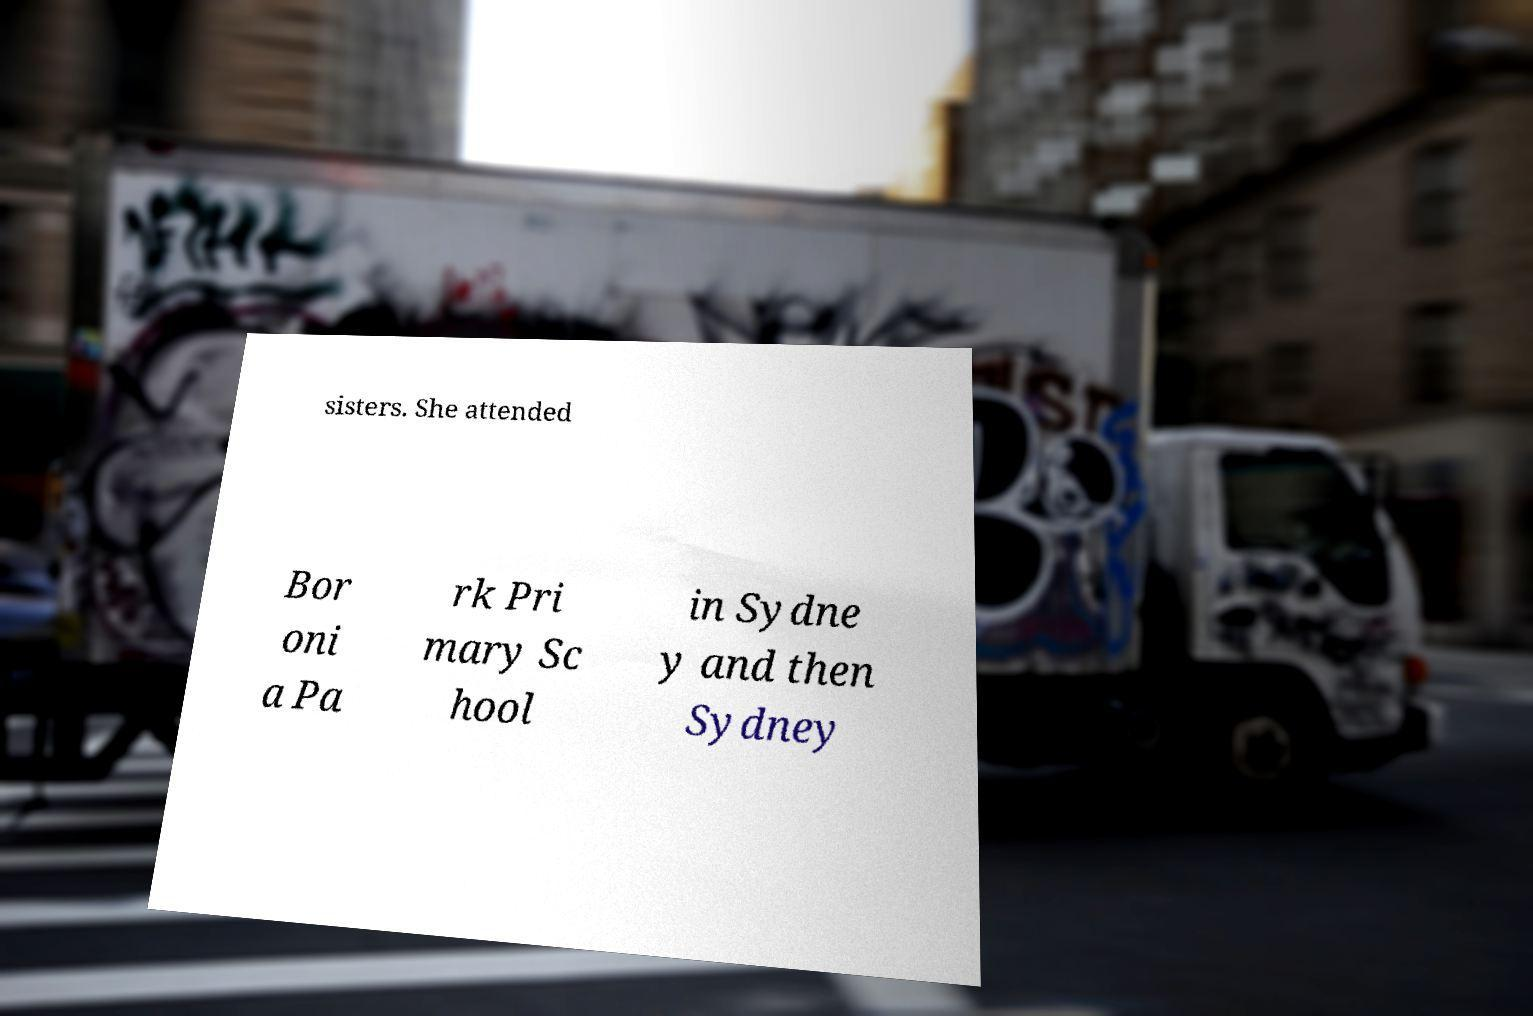Can you read and provide the text displayed in the image?This photo seems to have some interesting text. Can you extract and type it out for me? sisters. She attended Bor oni a Pa rk Pri mary Sc hool in Sydne y and then Sydney 